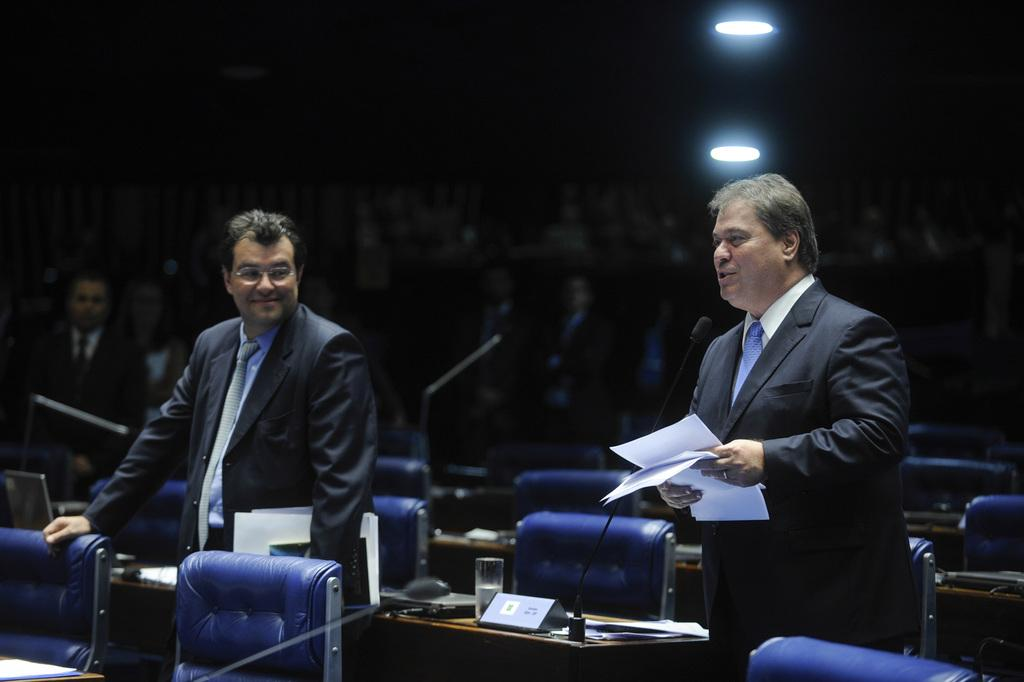What can be seen in the image involving people? There are people standing in the image. What type of furniture is present in the image? There are chairs and tables in the image. What items are on the tables? There are microphones and glasses on the tables. Can you describe the background of the image? The background of the image is blurred. What is visible at the top of the image? There are lights visible at the top of the image. What type of lead can be seen connecting the microphones in the image? There is no lead connecting the microphones in the image; they are simply placed on the tables. 